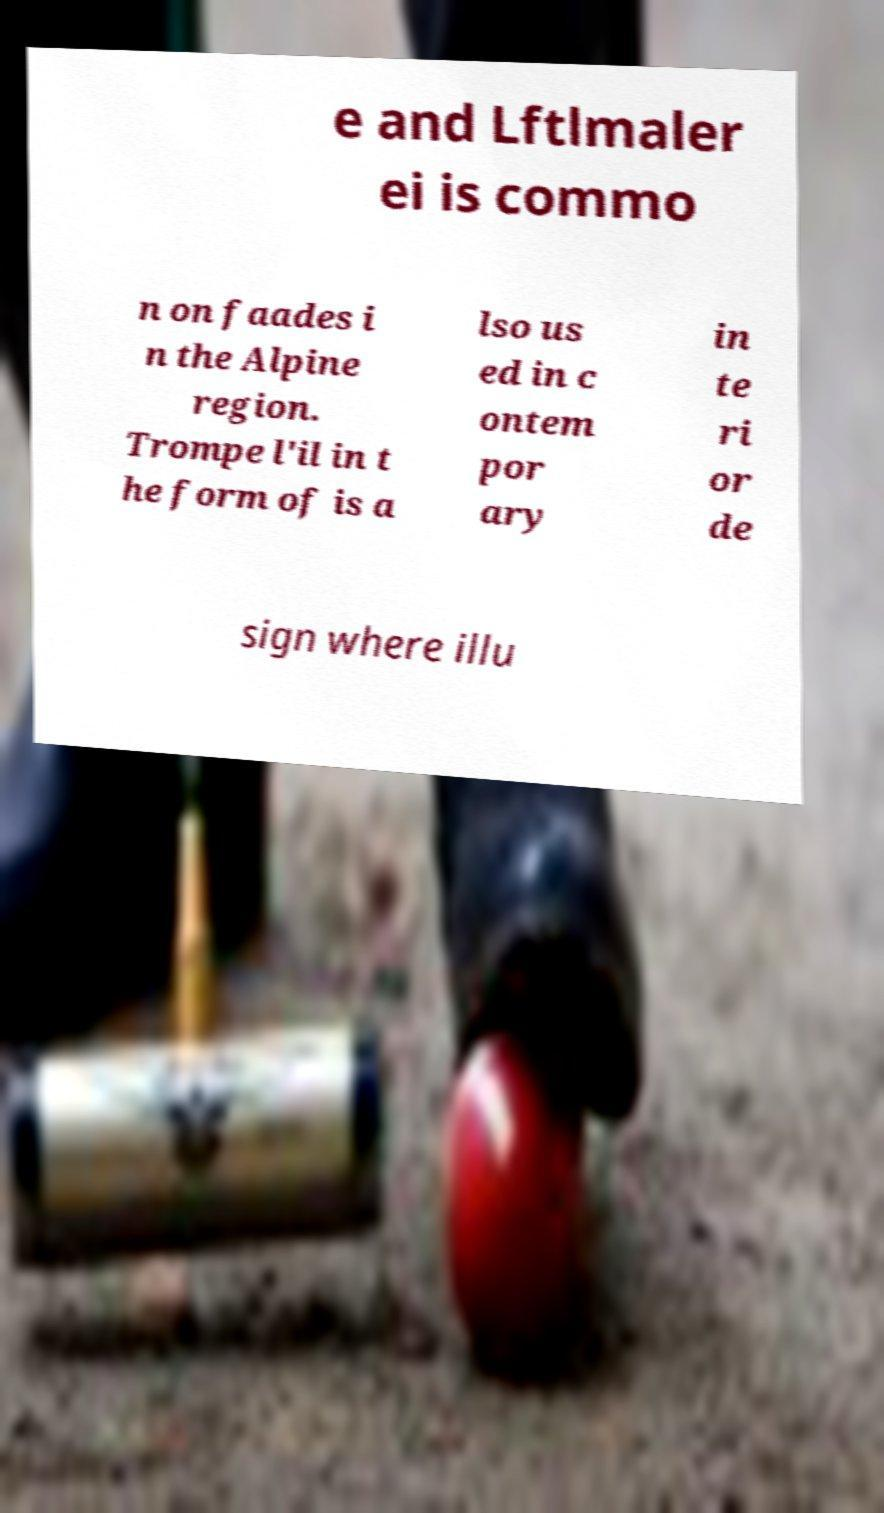Please identify and transcribe the text found in this image. e and Lftlmaler ei is commo n on faades i n the Alpine region. Trompe l'il in t he form of is a lso us ed in c ontem por ary in te ri or de sign where illu 